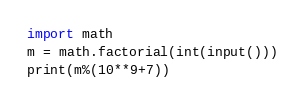<code> <loc_0><loc_0><loc_500><loc_500><_Python_>import math
m = math.factorial(int(input()))
print(m%(10**9+7))</code> 